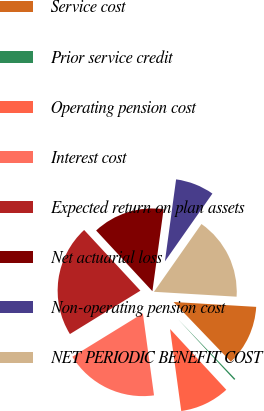Convert chart. <chart><loc_0><loc_0><loc_500><loc_500><pie_chart><fcel>Service cost<fcel>Prior service credit<fcel>Operating pension cost<fcel>Interest cost<fcel>Expected return on plan assets<fcel>Net actuarial loss<fcel>Non-operating pension cost<fcel>NET PERIODIC BENEFIT COST<nl><fcel>11.89%<fcel>0.28%<fcel>9.73%<fcel>18.37%<fcel>21.88%<fcel>14.05%<fcel>7.57%<fcel>16.21%<nl></chart> 